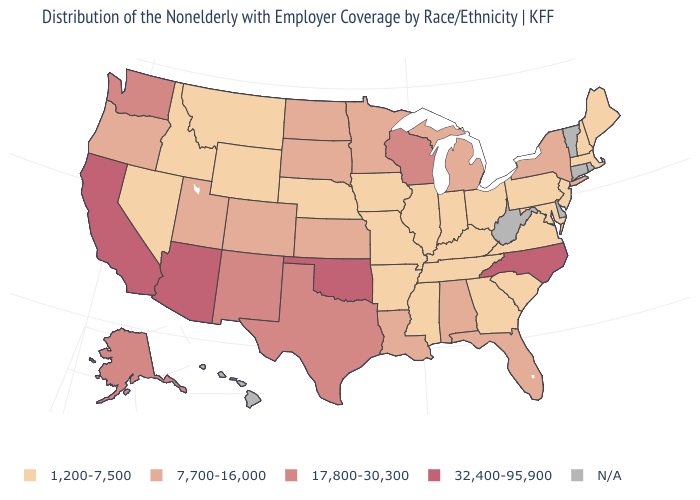Does the map have missing data?
Short answer required. Yes. How many symbols are there in the legend?
Answer briefly. 5. Does Pennsylvania have the lowest value in the Northeast?
Give a very brief answer. Yes. What is the value of Florida?
Be succinct. 7,700-16,000. Is the legend a continuous bar?
Give a very brief answer. No. What is the highest value in the USA?
Be succinct. 32,400-95,900. Which states have the highest value in the USA?
Be succinct. Arizona, California, North Carolina, Oklahoma. Which states hav the highest value in the South?
Answer briefly. North Carolina, Oklahoma. What is the value of Delaware?
Answer briefly. N/A. Does the map have missing data?
Be succinct. Yes. What is the value of Wisconsin?
Give a very brief answer. 17,800-30,300. What is the lowest value in the South?
Be succinct. 1,200-7,500. Which states hav the highest value in the West?
Quick response, please. Arizona, California. Does Washington have the highest value in the USA?
Short answer required. No. 